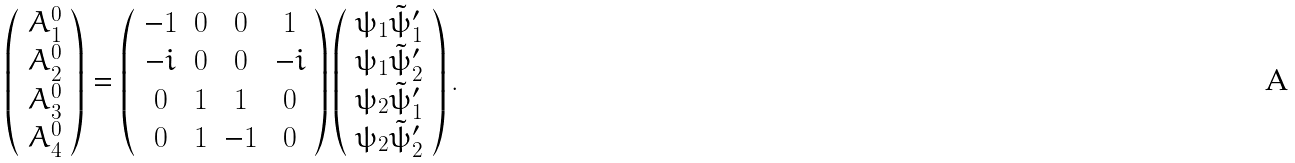<formula> <loc_0><loc_0><loc_500><loc_500>\left ( \begin{array} { c } A _ { 1 } ^ { 0 } \\ A _ { 2 } ^ { 0 } \\ A _ { 3 } ^ { 0 } \\ A _ { 4 } ^ { 0 } \end{array} \right ) = \left ( \begin{array} { c c c c } - 1 & 0 & 0 & 1 \\ - i & 0 & 0 & - i \\ 0 & 1 & 1 & 0 \\ 0 & 1 & - 1 & 0 \end{array} \right ) \left ( \begin{array} { c } \psi _ { 1 } { \tilde { \psi } } ^ { \prime } _ { 1 } \\ \psi _ { 1 } { \tilde { \psi } } ^ { \prime } _ { 2 } \\ \psi _ { 2 } { \tilde { \psi } } ^ { \prime } _ { 1 } \\ \psi _ { 2 } { \tilde { \psi } } ^ { \prime } _ { 2 } \end{array} \right ) .</formula> 